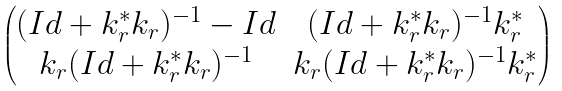Convert formula to latex. <formula><loc_0><loc_0><loc_500><loc_500>\begin{pmatrix} ( I d + k _ { r } ^ { * } k _ { r } ) ^ { - 1 } - I d & ( I d + k _ { r } ^ { * } k _ { r } ) ^ { - 1 } k _ { r } ^ { * } \\ k _ { r } ( I d + k _ { r } ^ { * } k _ { r } ) ^ { - 1 } & k _ { r } ( I d + k _ { r } ^ { * } k _ { r } ) ^ { - 1 } k _ { r } ^ { * } \end{pmatrix}</formula> 